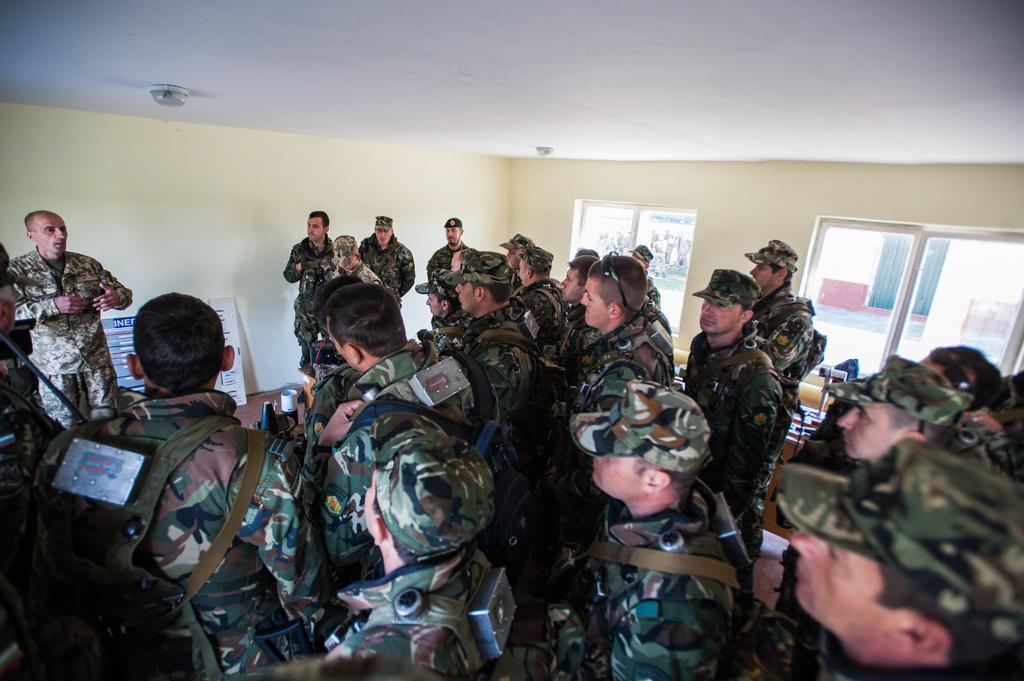How would you summarize this image in a sentence or two? In this picture there are group of people standing and we can see board and objects on the floor. In the background of the image we can see wall and glass windows. At the top we can see lights. 